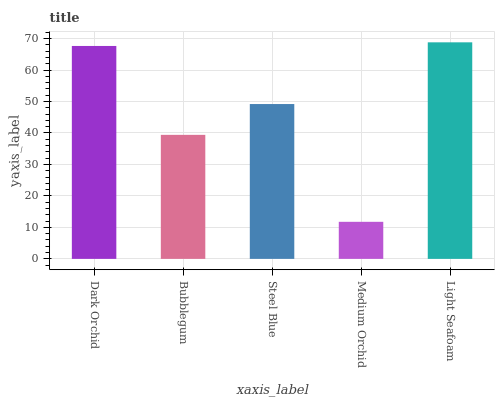Is Bubblegum the minimum?
Answer yes or no. No. Is Bubblegum the maximum?
Answer yes or no. No. Is Dark Orchid greater than Bubblegum?
Answer yes or no. Yes. Is Bubblegum less than Dark Orchid?
Answer yes or no. Yes. Is Bubblegum greater than Dark Orchid?
Answer yes or no. No. Is Dark Orchid less than Bubblegum?
Answer yes or no. No. Is Steel Blue the high median?
Answer yes or no. Yes. Is Steel Blue the low median?
Answer yes or no. Yes. Is Medium Orchid the high median?
Answer yes or no. No. Is Light Seafoam the low median?
Answer yes or no. No. 